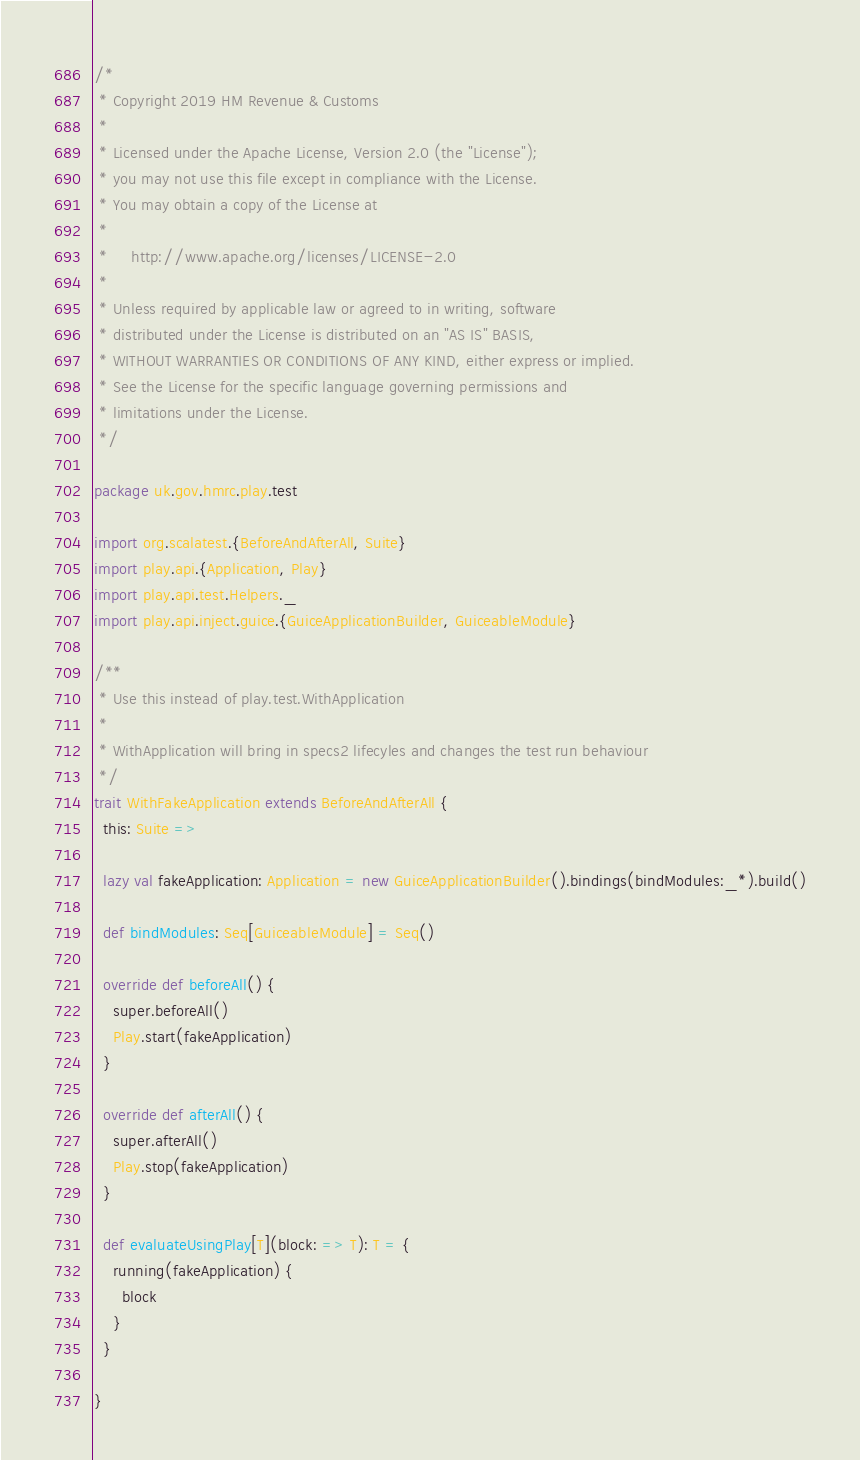<code> <loc_0><loc_0><loc_500><loc_500><_Scala_>/*
 * Copyright 2019 HM Revenue & Customs
 *
 * Licensed under the Apache License, Version 2.0 (the "License");
 * you may not use this file except in compliance with the License.
 * You may obtain a copy of the License at
 *
 *     http://www.apache.org/licenses/LICENSE-2.0
 *
 * Unless required by applicable law or agreed to in writing, software
 * distributed under the License is distributed on an "AS IS" BASIS,
 * WITHOUT WARRANTIES OR CONDITIONS OF ANY KIND, either express or implied.
 * See the License for the specific language governing permissions and
 * limitations under the License.
 */

package uk.gov.hmrc.play.test

import org.scalatest.{BeforeAndAfterAll, Suite}
import play.api.{Application, Play}
import play.api.test.Helpers._
import play.api.inject.guice.{GuiceApplicationBuilder, GuiceableModule}

/**
 * Use this instead of play.test.WithApplication
 *
 * WithApplication will bring in specs2 lifecyles and changes the test run behaviour
 */
trait WithFakeApplication extends BeforeAndAfterAll {
  this: Suite =>

  lazy val fakeApplication: Application = new GuiceApplicationBuilder().bindings(bindModules:_*).build()

  def bindModules: Seq[GuiceableModule] = Seq()

  override def beforeAll() {
    super.beforeAll()
    Play.start(fakeApplication)
  }

  override def afterAll() {
    super.afterAll()
    Play.stop(fakeApplication)
  }

  def evaluateUsingPlay[T](block: => T): T = {
    running(fakeApplication) {
      block
    }
  }

}
</code> 